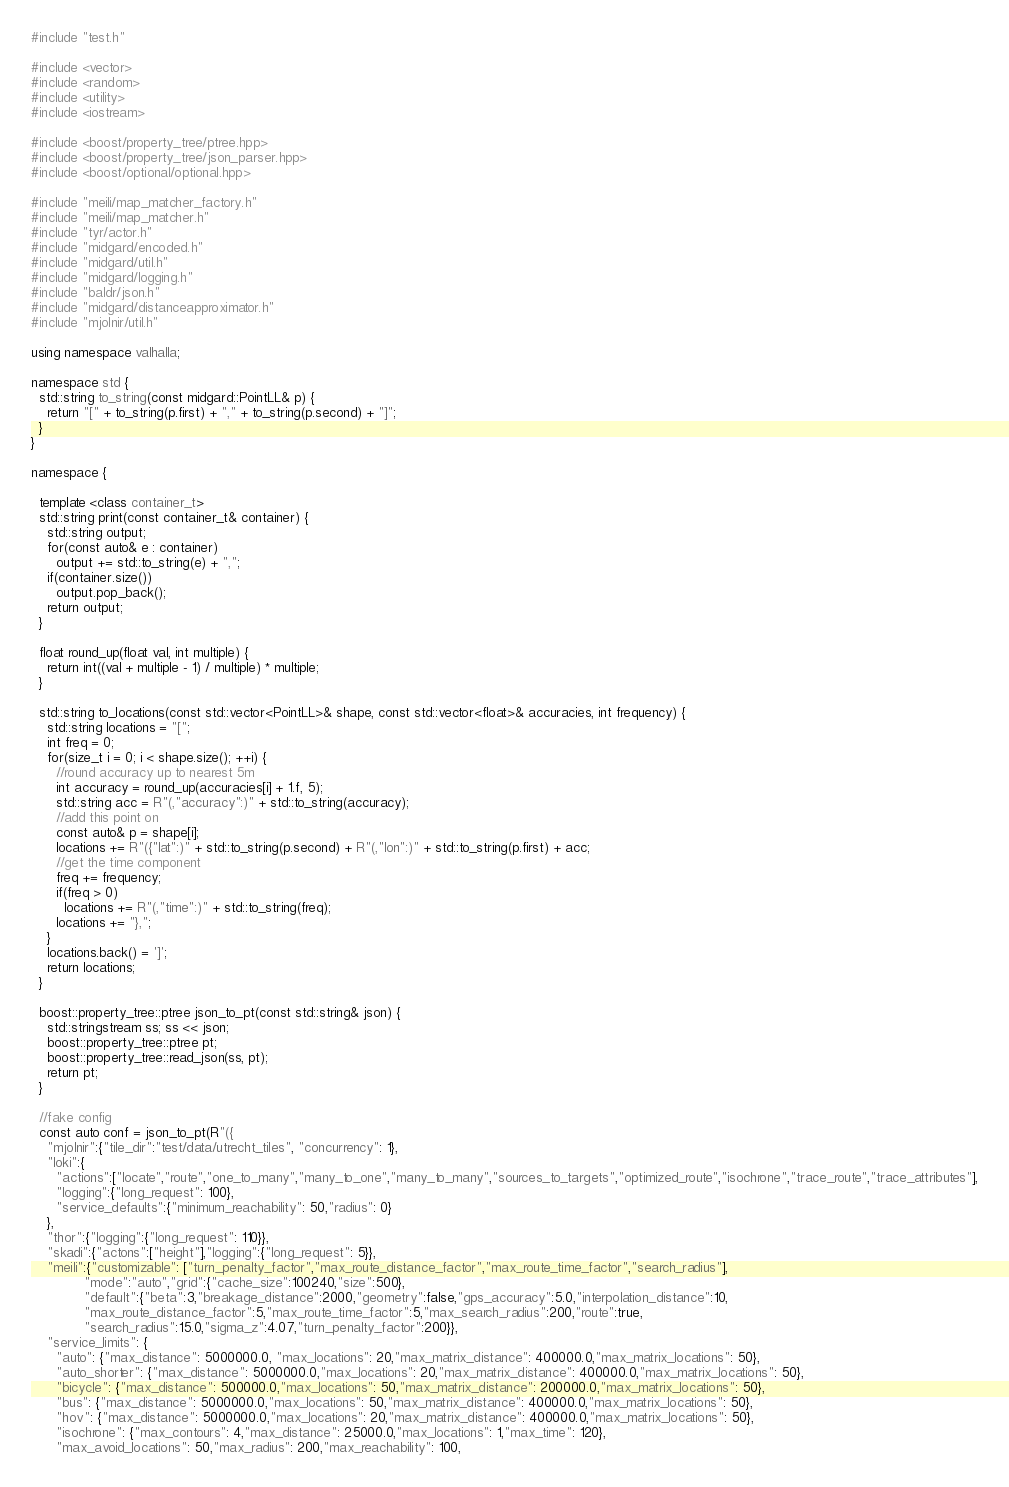<code> <loc_0><loc_0><loc_500><loc_500><_C++_>#include "test.h"

#include <vector>
#include <random>
#include <utility>
#include <iostream>

#include <boost/property_tree/ptree.hpp>
#include <boost/property_tree/json_parser.hpp>
#include <boost/optional/optional.hpp>

#include "meili/map_matcher_factory.h"
#include "meili/map_matcher.h"
#include "tyr/actor.h"
#include "midgard/encoded.h"
#include "midgard/util.h"
#include "midgard/logging.h"
#include "baldr/json.h"
#include "midgard/distanceapproximator.h"
#include "mjolnir/util.h"

using namespace valhalla;

namespace std {
  std::string to_string(const midgard::PointLL& p) {
    return "[" + to_string(p.first) + "," + to_string(p.second) + "]";
  }
}

namespace {

  template <class container_t>
  std::string print(const container_t& container) {
    std::string output;
    for(const auto& e : container)
      output += std::to_string(e) + ",";
    if(container.size())
      output.pop_back();
    return output;
  }

  float round_up(float val, int multiple) {
    return int((val + multiple - 1) / multiple) * multiple;
  }

  std::string to_locations(const std::vector<PointLL>& shape, const std::vector<float>& accuracies, int frequency) {
    std::string locations = "[";
    int freq = 0;
    for(size_t i = 0; i < shape.size(); ++i) {
      //round accuracy up to nearest 5m
      int accuracy = round_up(accuracies[i] + 1.f, 5);
      std::string acc = R"(,"accuracy":)" + std::to_string(accuracy);
      //add this point on
      const auto& p = shape[i];
      locations += R"({"lat":)" + std::to_string(p.second) + R"(,"lon":)" + std::to_string(p.first) + acc;
      //get the time component
      freq += frequency;
      if(freq > 0)
        locations += R"(,"time":)" + std::to_string(freq);
      locations += "},";
    }
    locations.back() = ']';
    return locations;
  }

  boost::property_tree::ptree json_to_pt(const std::string& json) {
    std::stringstream ss; ss << json;
    boost::property_tree::ptree pt;
    boost::property_tree::read_json(ss, pt);
    return pt;
  }

  //fake config
  const auto conf = json_to_pt(R"({
    "mjolnir":{"tile_dir":"test/data/utrecht_tiles", "concurrency": 1},
    "loki":{
      "actions":["locate","route","one_to_many","many_to_one","many_to_many","sources_to_targets","optimized_route","isochrone","trace_route","trace_attributes"],
      "logging":{"long_request": 100},
      "service_defaults":{"minimum_reachability": 50,"radius": 0}
    },
    "thor":{"logging":{"long_request": 110}},
    "skadi":{"actons":["height"],"logging":{"long_request": 5}},
    "meili":{"customizable": ["turn_penalty_factor","max_route_distance_factor","max_route_time_factor","search_radius"],
             "mode":"auto","grid":{"cache_size":100240,"size":500},
             "default":{"beta":3,"breakage_distance":2000,"geometry":false,"gps_accuracy":5.0,"interpolation_distance":10,
             "max_route_distance_factor":5,"max_route_time_factor":5,"max_search_radius":200,"route":true,
             "search_radius":15.0,"sigma_z":4.07,"turn_penalty_factor":200}},
    "service_limits": {
      "auto": {"max_distance": 5000000.0, "max_locations": 20,"max_matrix_distance": 400000.0,"max_matrix_locations": 50},
      "auto_shorter": {"max_distance": 5000000.0,"max_locations": 20,"max_matrix_distance": 400000.0,"max_matrix_locations": 50},
      "bicycle": {"max_distance": 500000.0,"max_locations": 50,"max_matrix_distance": 200000.0,"max_matrix_locations": 50},
      "bus": {"max_distance": 5000000.0,"max_locations": 50,"max_matrix_distance": 400000.0,"max_matrix_locations": 50},
      "hov": {"max_distance": 5000000.0,"max_locations": 20,"max_matrix_distance": 400000.0,"max_matrix_locations": 50},
      "isochrone": {"max_contours": 4,"max_distance": 25000.0,"max_locations": 1,"max_time": 120},
      "max_avoid_locations": 50,"max_radius": 200,"max_reachability": 100,</code> 